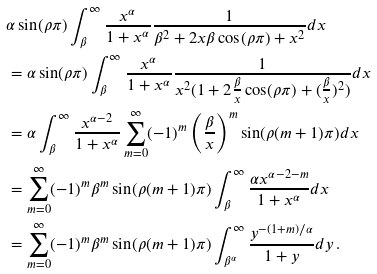<formula> <loc_0><loc_0><loc_500><loc_500>& \alpha \sin ( \rho \pi ) \int _ { \beta } ^ { \infty } \frac { x ^ { \alpha } } { 1 + x ^ { \alpha } } \frac { 1 } { \beta ^ { 2 } + 2 x \beta \cos ( \rho \pi ) + x ^ { 2 } } d x \\ & = \alpha \sin ( \rho \pi ) \int _ { \beta } ^ { \infty } \frac { x ^ { \alpha } } { 1 + x ^ { \alpha } } \frac { 1 } { x ^ { 2 } ( 1 + 2 \frac { \beta } { x } \cos ( \rho \pi ) + ( \frac { \beta } { x } ) ^ { 2 } ) } d x \\ & = \alpha \int _ { \beta } ^ { \infty } \frac { x ^ { \alpha - 2 } } { 1 + x ^ { \alpha } } \sum _ { m = 0 } ^ { \infty } ( - 1 ) ^ { m } \left ( \frac { \beta } { x } \right ) ^ { m } \sin ( \rho ( m + 1 ) \pi ) d x \\ & = \sum _ { m = 0 } ^ { \infty } ( - 1 ) ^ { m } \beta ^ { m } \sin ( \rho ( m + 1 ) \pi ) \int _ { \beta } ^ { \infty } \frac { \alpha x ^ { \alpha - 2 - m } } { 1 + x ^ { \alpha } } d x \\ & = \sum _ { m = 0 } ^ { \infty } ( - 1 ) ^ { m } \beta ^ { m } \sin ( \rho ( m + 1 ) \pi ) \int _ { \beta ^ { \alpha } } ^ { \infty } \frac { y ^ { - ( 1 + m ) / \alpha } } { 1 + y } d y \, .</formula> 